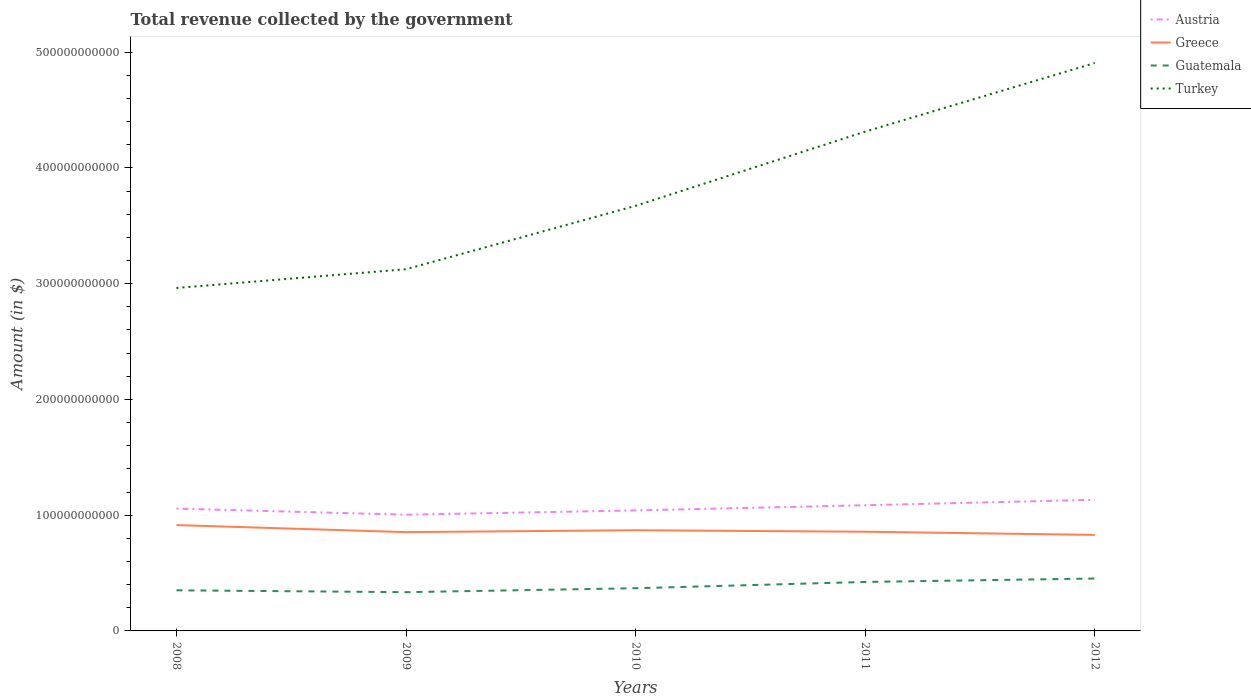How many different coloured lines are there?
Provide a short and direct response. 4. Does the line corresponding to Austria intersect with the line corresponding to Greece?
Provide a short and direct response. No. Is the number of lines equal to the number of legend labels?
Provide a succinct answer. Yes. Across all years, what is the maximum total revenue collected by the government in Austria?
Your answer should be very brief. 1.00e+11. In which year was the total revenue collected by the government in Greece maximum?
Offer a terse response. 2012. What is the total total revenue collected by the government in Greece in the graph?
Ensure brevity in your answer.  2.75e+09. What is the difference between the highest and the second highest total revenue collected by the government in Turkey?
Your response must be concise. 1.94e+11. Is the total revenue collected by the government in Turkey strictly greater than the total revenue collected by the government in Guatemala over the years?
Keep it short and to the point. No. How many years are there in the graph?
Your answer should be compact. 5. What is the difference between two consecutive major ticks on the Y-axis?
Offer a terse response. 1.00e+11. Does the graph contain any zero values?
Provide a short and direct response. No. How many legend labels are there?
Give a very brief answer. 4. How are the legend labels stacked?
Ensure brevity in your answer.  Vertical. What is the title of the graph?
Keep it short and to the point. Total revenue collected by the government. Does "St. Martin (French part)" appear as one of the legend labels in the graph?
Give a very brief answer. No. What is the label or title of the X-axis?
Keep it short and to the point. Years. What is the label or title of the Y-axis?
Offer a very short reply. Amount (in $). What is the Amount (in $) in Austria in 2008?
Make the answer very short. 1.06e+11. What is the Amount (in $) of Greece in 2008?
Your response must be concise. 9.14e+1. What is the Amount (in $) in Guatemala in 2008?
Your answer should be compact. 3.51e+1. What is the Amount (in $) in Turkey in 2008?
Your answer should be very brief. 2.96e+11. What is the Amount (in $) of Austria in 2009?
Offer a terse response. 1.00e+11. What is the Amount (in $) of Greece in 2009?
Make the answer very short. 8.53e+1. What is the Amount (in $) of Guatemala in 2009?
Make the answer very short. 3.35e+1. What is the Amount (in $) of Turkey in 2009?
Offer a terse response. 3.12e+11. What is the Amount (in $) of Austria in 2010?
Provide a succinct answer. 1.04e+11. What is the Amount (in $) in Greece in 2010?
Make the answer very short. 8.70e+1. What is the Amount (in $) in Guatemala in 2010?
Offer a very short reply. 3.69e+1. What is the Amount (in $) in Turkey in 2010?
Make the answer very short. 3.67e+11. What is the Amount (in $) in Austria in 2011?
Provide a short and direct response. 1.09e+11. What is the Amount (in $) in Greece in 2011?
Your response must be concise. 8.57e+1. What is the Amount (in $) of Guatemala in 2011?
Your answer should be compact. 4.23e+1. What is the Amount (in $) in Turkey in 2011?
Keep it short and to the point. 4.31e+11. What is the Amount (in $) of Austria in 2012?
Your answer should be compact. 1.13e+11. What is the Amount (in $) in Greece in 2012?
Your response must be concise. 8.29e+1. What is the Amount (in $) in Guatemala in 2012?
Offer a terse response. 4.53e+1. What is the Amount (in $) of Turkey in 2012?
Provide a short and direct response. 4.91e+11. Across all years, what is the maximum Amount (in $) in Austria?
Your response must be concise. 1.13e+11. Across all years, what is the maximum Amount (in $) in Greece?
Make the answer very short. 9.14e+1. Across all years, what is the maximum Amount (in $) of Guatemala?
Provide a short and direct response. 4.53e+1. Across all years, what is the maximum Amount (in $) of Turkey?
Provide a succinct answer. 4.91e+11. Across all years, what is the minimum Amount (in $) of Austria?
Provide a short and direct response. 1.00e+11. Across all years, what is the minimum Amount (in $) of Greece?
Ensure brevity in your answer.  8.29e+1. Across all years, what is the minimum Amount (in $) of Guatemala?
Offer a terse response. 3.35e+1. Across all years, what is the minimum Amount (in $) of Turkey?
Keep it short and to the point. 2.96e+11. What is the total Amount (in $) in Austria in the graph?
Provide a succinct answer. 5.32e+11. What is the total Amount (in $) of Greece in the graph?
Your answer should be compact. 4.32e+11. What is the total Amount (in $) in Guatemala in the graph?
Your answer should be compact. 1.93e+11. What is the total Amount (in $) of Turkey in the graph?
Your response must be concise. 1.90e+12. What is the difference between the Amount (in $) of Austria in 2008 and that in 2009?
Your response must be concise. 5.25e+09. What is the difference between the Amount (in $) of Greece in 2008 and that in 2009?
Make the answer very short. 6.07e+09. What is the difference between the Amount (in $) in Guatemala in 2008 and that in 2009?
Provide a succinct answer. 1.61e+09. What is the difference between the Amount (in $) in Turkey in 2008 and that in 2009?
Ensure brevity in your answer.  -1.62e+1. What is the difference between the Amount (in $) in Austria in 2008 and that in 2010?
Ensure brevity in your answer.  1.57e+09. What is the difference between the Amount (in $) in Greece in 2008 and that in 2010?
Ensure brevity in your answer.  4.44e+09. What is the difference between the Amount (in $) of Guatemala in 2008 and that in 2010?
Offer a very short reply. -1.79e+09. What is the difference between the Amount (in $) of Turkey in 2008 and that in 2010?
Provide a short and direct response. -7.10e+1. What is the difference between the Amount (in $) of Austria in 2008 and that in 2011?
Offer a very short reply. -2.92e+09. What is the difference between the Amount (in $) of Greece in 2008 and that in 2011?
Make the answer very short. 5.73e+09. What is the difference between the Amount (in $) of Guatemala in 2008 and that in 2011?
Give a very brief answer. -7.21e+09. What is the difference between the Amount (in $) of Turkey in 2008 and that in 2011?
Keep it short and to the point. -1.35e+11. What is the difference between the Amount (in $) of Austria in 2008 and that in 2012?
Make the answer very short. -7.61e+09. What is the difference between the Amount (in $) of Greece in 2008 and that in 2012?
Give a very brief answer. 8.48e+09. What is the difference between the Amount (in $) of Guatemala in 2008 and that in 2012?
Ensure brevity in your answer.  -1.02e+1. What is the difference between the Amount (in $) in Turkey in 2008 and that in 2012?
Keep it short and to the point. -1.94e+11. What is the difference between the Amount (in $) in Austria in 2009 and that in 2010?
Give a very brief answer. -3.68e+09. What is the difference between the Amount (in $) of Greece in 2009 and that in 2010?
Your answer should be very brief. -1.63e+09. What is the difference between the Amount (in $) in Guatemala in 2009 and that in 2010?
Your answer should be compact. -3.40e+09. What is the difference between the Amount (in $) in Turkey in 2009 and that in 2010?
Your answer should be very brief. -5.48e+1. What is the difference between the Amount (in $) in Austria in 2009 and that in 2011?
Your answer should be very brief. -8.17e+09. What is the difference between the Amount (in $) in Greece in 2009 and that in 2011?
Make the answer very short. -3.43e+08. What is the difference between the Amount (in $) of Guatemala in 2009 and that in 2011?
Ensure brevity in your answer.  -8.81e+09. What is the difference between the Amount (in $) in Turkey in 2009 and that in 2011?
Your response must be concise. -1.19e+11. What is the difference between the Amount (in $) in Austria in 2009 and that in 2012?
Ensure brevity in your answer.  -1.29e+1. What is the difference between the Amount (in $) of Greece in 2009 and that in 2012?
Make the answer very short. 2.40e+09. What is the difference between the Amount (in $) of Guatemala in 2009 and that in 2012?
Offer a very short reply. -1.18e+1. What is the difference between the Amount (in $) of Turkey in 2009 and that in 2012?
Give a very brief answer. -1.78e+11. What is the difference between the Amount (in $) of Austria in 2010 and that in 2011?
Make the answer very short. -4.49e+09. What is the difference between the Amount (in $) of Greece in 2010 and that in 2011?
Ensure brevity in your answer.  1.28e+09. What is the difference between the Amount (in $) in Guatemala in 2010 and that in 2011?
Provide a succinct answer. -5.42e+09. What is the difference between the Amount (in $) in Turkey in 2010 and that in 2011?
Provide a succinct answer. -6.41e+1. What is the difference between the Amount (in $) of Austria in 2010 and that in 2012?
Offer a very short reply. -9.19e+09. What is the difference between the Amount (in $) of Greece in 2010 and that in 2012?
Offer a very short reply. 4.03e+09. What is the difference between the Amount (in $) of Guatemala in 2010 and that in 2012?
Your answer should be very brief. -8.40e+09. What is the difference between the Amount (in $) in Turkey in 2010 and that in 2012?
Give a very brief answer. -1.23e+11. What is the difference between the Amount (in $) of Austria in 2011 and that in 2012?
Provide a short and direct response. -4.69e+09. What is the difference between the Amount (in $) of Greece in 2011 and that in 2012?
Ensure brevity in your answer.  2.75e+09. What is the difference between the Amount (in $) in Guatemala in 2011 and that in 2012?
Ensure brevity in your answer.  -2.98e+09. What is the difference between the Amount (in $) in Turkey in 2011 and that in 2012?
Your response must be concise. -5.93e+1. What is the difference between the Amount (in $) of Austria in 2008 and the Amount (in $) of Greece in 2009?
Give a very brief answer. 2.03e+1. What is the difference between the Amount (in $) in Austria in 2008 and the Amount (in $) in Guatemala in 2009?
Give a very brief answer. 7.22e+1. What is the difference between the Amount (in $) in Austria in 2008 and the Amount (in $) in Turkey in 2009?
Provide a succinct answer. -2.07e+11. What is the difference between the Amount (in $) of Greece in 2008 and the Amount (in $) of Guatemala in 2009?
Provide a short and direct response. 5.79e+1. What is the difference between the Amount (in $) of Greece in 2008 and the Amount (in $) of Turkey in 2009?
Give a very brief answer. -2.21e+11. What is the difference between the Amount (in $) of Guatemala in 2008 and the Amount (in $) of Turkey in 2009?
Make the answer very short. -2.77e+11. What is the difference between the Amount (in $) in Austria in 2008 and the Amount (in $) in Greece in 2010?
Provide a succinct answer. 1.87e+1. What is the difference between the Amount (in $) in Austria in 2008 and the Amount (in $) in Guatemala in 2010?
Provide a short and direct response. 6.88e+1. What is the difference between the Amount (in $) in Austria in 2008 and the Amount (in $) in Turkey in 2010?
Offer a very short reply. -2.62e+11. What is the difference between the Amount (in $) in Greece in 2008 and the Amount (in $) in Guatemala in 2010?
Your response must be concise. 5.45e+1. What is the difference between the Amount (in $) in Greece in 2008 and the Amount (in $) in Turkey in 2010?
Offer a terse response. -2.76e+11. What is the difference between the Amount (in $) of Guatemala in 2008 and the Amount (in $) of Turkey in 2010?
Your response must be concise. -3.32e+11. What is the difference between the Amount (in $) in Austria in 2008 and the Amount (in $) in Greece in 2011?
Offer a very short reply. 2.00e+1. What is the difference between the Amount (in $) of Austria in 2008 and the Amount (in $) of Guatemala in 2011?
Your answer should be compact. 6.34e+1. What is the difference between the Amount (in $) of Austria in 2008 and the Amount (in $) of Turkey in 2011?
Offer a very short reply. -3.26e+11. What is the difference between the Amount (in $) in Greece in 2008 and the Amount (in $) in Guatemala in 2011?
Provide a short and direct response. 4.91e+1. What is the difference between the Amount (in $) in Greece in 2008 and the Amount (in $) in Turkey in 2011?
Give a very brief answer. -3.40e+11. What is the difference between the Amount (in $) of Guatemala in 2008 and the Amount (in $) of Turkey in 2011?
Make the answer very short. -3.96e+11. What is the difference between the Amount (in $) of Austria in 2008 and the Amount (in $) of Greece in 2012?
Provide a short and direct response. 2.27e+1. What is the difference between the Amount (in $) in Austria in 2008 and the Amount (in $) in Guatemala in 2012?
Provide a succinct answer. 6.04e+1. What is the difference between the Amount (in $) of Austria in 2008 and the Amount (in $) of Turkey in 2012?
Ensure brevity in your answer.  -3.85e+11. What is the difference between the Amount (in $) in Greece in 2008 and the Amount (in $) in Guatemala in 2012?
Provide a short and direct response. 4.61e+1. What is the difference between the Amount (in $) of Greece in 2008 and the Amount (in $) of Turkey in 2012?
Offer a terse response. -3.99e+11. What is the difference between the Amount (in $) in Guatemala in 2008 and the Amount (in $) in Turkey in 2012?
Offer a terse response. -4.55e+11. What is the difference between the Amount (in $) of Austria in 2009 and the Amount (in $) of Greece in 2010?
Keep it short and to the point. 1.34e+1. What is the difference between the Amount (in $) of Austria in 2009 and the Amount (in $) of Guatemala in 2010?
Ensure brevity in your answer.  6.35e+1. What is the difference between the Amount (in $) in Austria in 2009 and the Amount (in $) in Turkey in 2010?
Your response must be concise. -2.67e+11. What is the difference between the Amount (in $) in Greece in 2009 and the Amount (in $) in Guatemala in 2010?
Offer a very short reply. 4.85e+1. What is the difference between the Amount (in $) of Greece in 2009 and the Amount (in $) of Turkey in 2010?
Ensure brevity in your answer.  -2.82e+11. What is the difference between the Amount (in $) of Guatemala in 2009 and the Amount (in $) of Turkey in 2010?
Your response must be concise. -3.34e+11. What is the difference between the Amount (in $) in Austria in 2009 and the Amount (in $) in Greece in 2011?
Ensure brevity in your answer.  1.47e+1. What is the difference between the Amount (in $) in Austria in 2009 and the Amount (in $) in Guatemala in 2011?
Your answer should be compact. 5.81e+1. What is the difference between the Amount (in $) in Austria in 2009 and the Amount (in $) in Turkey in 2011?
Make the answer very short. -3.31e+11. What is the difference between the Amount (in $) in Greece in 2009 and the Amount (in $) in Guatemala in 2011?
Offer a very short reply. 4.30e+1. What is the difference between the Amount (in $) in Greece in 2009 and the Amount (in $) in Turkey in 2011?
Offer a very short reply. -3.46e+11. What is the difference between the Amount (in $) in Guatemala in 2009 and the Amount (in $) in Turkey in 2011?
Your answer should be very brief. -3.98e+11. What is the difference between the Amount (in $) in Austria in 2009 and the Amount (in $) in Greece in 2012?
Give a very brief answer. 1.75e+1. What is the difference between the Amount (in $) of Austria in 2009 and the Amount (in $) of Guatemala in 2012?
Give a very brief answer. 5.51e+1. What is the difference between the Amount (in $) in Austria in 2009 and the Amount (in $) in Turkey in 2012?
Your response must be concise. -3.90e+11. What is the difference between the Amount (in $) of Greece in 2009 and the Amount (in $) of Guatemala in 2012?
Make the answer very short. 4.01e+1. What is the difference between the Amount (in $) of Greece in 2009 and the Amount (in $) of Turkey in 2012?
Your response must be concise. -4.05e+11. What is the difference between the Amount (in $) of Guatemala in 2009 and the Amount (in $) of Turkey in 2012?
Your response must be concise. -4.57e+11. What is the difference between the Amount (in $) in Austria in 2010 and the Amount (in $) in Greece in 2011?
Make the answer very short. 1.84e+1. What is the difference between the Amount (in $) of Austria in 2010 and the Amount (in $) of Guatemala in 2011?
Provide a succinct answer. 6.18e+1. What is the difference between the Amount (in $) of Austria in 2010 and the Amount (in $) of Turkey in 2011?
Make the answer very short. -3.27e+11. What is the difference between the Amount (in $) in Greece in 2010 and the Amount (in $) in Guatemala in 2011?
Your response must be concise. 4.47e+1. What is the difference between the Amount (in $) of Greece in 2010 and the Amount (in $) of Turkey in 2011?
Offer a terse response. -3.44e+11. What is the difference between the Amount (in $) of Guatemala in 2010 and the Amount (in $) of Turkey in 2011?
Ensure brevity in your answer.  -3.94e+11. What is the difference between the Amount (in $) in Austria in 2010 and the Amount (in $) in Greece in 2012?
Keep it short and to the point. 2.11e+1. What is the difference between the Amount (in $) of Austria in 2010 and the Amount (in $) of Guatemala in 2012?
Offer a terse response. 5.88e+1. What is the difference between the Amount (in $) of Austria in 2010 and the Amount (in $) of Turkey in 2012?
Make the answer very short. -3.86e+11. What is the difference between the Amount (in $) of Greece in 2010 and the Amount (in $) of Guatemala in 2012?
Your response must be concise. 4.17e+1. What is the difference between the Amount (in $) of Greece in 2010 and the Amount (in $) of Turkey in 2012?
Provide a short and direct response. -4.04e+11. What is the difference between the Amount (in $) in Guatemala in 2010 and the Amount (in $) in Turkey in 2012?
Your response must be concise. -4.54e+11. What is the difference between the Amount (in $) in Austria in 2011 and the Amount (in $) in Greece in 2012?
Make the answer very short. 2.56e+1. What is the difference between the Amount (in $) of Austria in 2011 and the Amount (in $) of Guatemala in 2012?
Your response must be concise. 6.33e+1. What is the difference between the Amount (in $) in Austria in 2011 and the Amount (in $) in Turkey in 2012?
Make the answer very short. -3.82e+11. What is the difference between the Amount (in $) of Greece in 2011 and the Amount (in $) of Guatemala in 2012?
Your response must be concise. 4.04e+1. What is the difference between the Amount (in $) in Greece in 2011 and the Amount (in $) in Turkey in 2012?
Ensure brevity in your answer.  -4.05e+11. What is the difference between the Amount (in $) in Guatemala in 2011 and the Amount (in $) in Turkey in 2012?
Make the answer very short. -4.48e+11. What is the average Amount (in $) in Austria per year?
Your answer should be compact. 1.06e+11. What is the average Amount (in $) of Greece per year?
Your answer should be very brief. 8.65e+1. What is the average Amount (in $) of Guatemala per year?
Ensure brevity in your answer.  3.86e+1. What is the average Amount (in $) in Turkey per year?
Give a very brief answer. 3.80e+11. In the year 2008, what is the difference between the Amount (in $) in Austria and Amount (in $) in Greece?
Offer a terse response. 1.42e+1. In the year 2008, what is the difference between the Amount (in $) in Austria and Amount (in $) in Guatemala?
Your answer should be compact. 7.06e+1. In the year 2008, what is the difference between the Amount (in $) in Austria and Amount (in $) in Turkey?
Keep it short and to the point. -1.91e+11. In the year 2008, what is the difference between the Amount (in $) in Greece and Amount (in $) in Guatemala?
Provide a succinct answer. 5.63e+1. In the year 2008, what is the difference between the Amount (in $) in Greece and Amount (in $) in Turkey?
Your answer should be very brief. -2.05e+11. In the year 2008, what is the difference between the Amount (in $) in Guatemala and Amount (in $) in Turkey?
Provide a succinct answer. -2.61e+11. In the year 2009, what is the difference between the Amount (in $) of Austria and Amount (in $) of Greece?
Your response must be concise. 1.51e+1. In the year 2009, what is the difference between the Amount (in $) of Austria and Amount (in $) of Guatemala?
Provide a succinct answer. 6.69e+1. In the year 2009, what is the difference between the Amount (in $) of Austria and Amount (in $) of Turkey?
Your answer should be very brief. -2.12e+11. In the year 2009, what is the difference between the Amount (in $) of Greece and Amount (in $) of Guatemala?
Offer a terse response. 5.19e+1. In the year 2009, what is the difference between the Amount (in $) in Greece and Amount (in $) in Turkey?
Make the answer very short. -2.27e+11. In the year 2009, what is the difference between the Amount (in $) of Guatemala and Amount (in $) of Turkey?
Make the answer very short. -2.79e+11. In the year 2010, what is the difference between the Amount (in $) of Austria and Amount (in $) of Greece?
Make the answer very short. 1.71e+1. In the year 2010, what is the difference between the Amount (in $) in Austria and Amount (in $) in Guatemala?
Your answer should be very brief. 6.72e+1. In the year 2010, what is the difference between the Amount (in $) of Austria and Amount (in $) of Turkey?
Your answer should be compact. -2.63e+11. In the year 2010, what is the difference between the Amount (in $) of Greece and Amount (in $) of Guatemala?
Your response must be concise. 5.01e+1. In the year 2010, what is the difference between the Amount (in $) of Greece and Amount (in $) of Turkey?
Your answer should be very brief. -2.80e+11. In the year 2010, what is the difference between the Amount (in $) of Guatemala and Amount (in $) of Turkey?
Ensure brevity in your answer.  -3.30e+11. In the year 2011, what is the difference between the Amount (in $) in Austria and Amount (in $) in Greece?
Provide a short and direct response. 2.29e+1. In the year 2011, what is the difference between the Amount (in $) in Austria and Amount (in $) in Guatemala?
Ensure brevity in your answer.  6.63e+1. In the year 2011, what is the difference between the Amount (in $) of Austria and Amount (in $) of Turkey?
Offer a very short reply. -3.23e+11. In the year 2011, what is the difference between the Amount (in $) in Greece and Amount (in $) in Guatemala?
Your response must be concise. 4.34e+1. In the year 2011, what is the difference between the Amount (in $) of Greece and Amount (in $) of Turkey?
Provide a succinct answer. -3.46e+11. In the year 2011, what is the difference between the Amount (in $) of Guatemala and Amount (in $) of Turkey?
Offer a very short reply. -3.89e+11. In the year 2012, what is the difference between the Amount (in $) in Austria and Amount (in $) in Greece?
Your response must be concise. 3.03e+1. In the year 2012, what is the difference between the Amount (in $) of Austria and Amount (in $) of Guatemala?
Offer a terse response. 6.80e+1. In the year 2012, what is the difference between the Amount (in $) of Austria and Amount (in $) of Turkey?
Offer a terse response. -3.77e+11. In the year 2012, what is the difference between the Amount (in $) of Greece and Amount (in $) of Guatemala?
Ensure brevity in your answer.  3.77e+1. In the year 2012, what is the difference between the Amount (in $) in Greece and Amount (in $) in Turkey?
Provide a short and direct response. -4.08e+11. In the year 2012, what is the difference between the Amount (in $) of Guatemala and Amount (in $) of Turkey?
Keep it short and to the point. -4.45e+11. What is the ratio of the Amount (in $) of Austria in 2008 to that in 2009?
Give a very brief answer. 1.05. What is the ratio of the Amount (in $) of Greece in 2008 to that in 2009?
Your response must be concise. 1.07. What is the ratio of the Amount (in $) in Guatemala in 2008 to that in 2009?
Your response must be concise. 1.05. What is the ratio of the Amount (in $) in Turkey in 2008 to that in 2009?
Make the answer very short. 0.95. What is the ratio of the Amount (in $) of Austria in 2008 to that in 2010?
Provide a short and direct response. 1.02. What is the ratio of the Amount (in $) of Greece in 2008 to that in 2010?
Ensure brevity in your answer.  1.05. What is the ratio of the Amount (in $) in Guatemala in 2008 to that in 2010?
Provide a succinct answer. 0.95. What is the ratio of the Amount (in $) in Turkey in 2008 to that in 2010?
Your answer should be very brief. 0.81. What is the ratio of the Amount (in $) in Austria in 2008 to that in 2011?
Keep it short and to the point. 0.97. What is the ratio of the Amount (in $) in Greece in 2008 to that in 2011?
Your answer should be very brief. 1.07. What is the ratio of the Amount (in $) in Guatemala in 2008 to that in 2011?
Offer a terse response. 0.83. What is the ratio of the Amount (in $) in Turkey in 2008 to that in 2011?
Offer a very short reply. 0.69. What is the ratio of the Amount (in $) in Austria in 2008 to that in 2012?
Provide a succinct answer. 0.93. What is the ratio of the Amount (in $) in Greece in 2008 to that in 2012?
Your response must be concise. 1.1. What is the ratio of the Amount (in $) in Guatemala in 2008 to that in 2012?
Offer a terse response. 0.78. What is the ratio of the Amount (in $) in Turkey in 2008 to that in 2012?
Keep it short and to the point. 0.6. What is the ratio of the Amount (in $) in Austria in 2009 to that in 2010?
Your response must be concise. 0.96. What is the ratio of the Amount (in $) in Greece in 2009 to that in 2010?
Give a very brief answer. 0.98. What is the ratio of the Amount (in $) in Guatemala in 2009 to that in 2010?
Keep it short and to the point. 0.91. What is the ratio of the Amount (in $) of Turkey in 2009 to that in 2010?
Offer a very short reply. 0.85. What is the ratio of the Amount (in $) in Austria in 2009 to that in 2011?
Offer a very short reply. 0.92. What is the ratio of the Amount (in $) in Greece in 2009 to that in 2011?
Your response must be concise. 1. What is the ratio of the Amount (in $) of Guatemala in 2009 to that in 2011?
Keep it short and to the point. 0.79. What is the ratio of the Amount (in $) in Turkey in 2009 to that in 2011?
Offer a very short reply. 0.72. What is the ratio of the Amount (in $) in Austria in 2009 to that in 2012?
Provide a short and direct response. 0.89. What is the ratio of the Amount (in $) in Greece in 2009 to that in 2012?
Offer a very short reply. 1.03. What is the ratio of the Amount (in $) in Guatemala in 2009 to that in 2012?
Offer a very short reply. 0.74. What is the ratio of the Amount (in $) of Turkey in 2009 to that in 2012?
Provide a succinct answer. 0.64. What is the ratio of the Amount (in $) in Austria in 2010 to that in 2011?
Give a very brief answer. 0.96. What is the ratio of the Amount (in $) of Greece in 2010 to that in 2011?
Your answer should be compact. 1.01. What is the ratio of the Amount (in $) of Guatemala in 2010 to that in 2011?
Offer a terse response. 0.87. What is the ratio of the Amount (in $) of Turkey in 2010 to that in 2011?
Keep it short and to the point. 0.85. What is the ratio of the Amount (in $) of Austria in 2010 to that in 2012?
Your response must be concise. 0.92. What is the ratio of the Amount (in $) of Greece in 2010 to that in 2012?
Your answer should be compact. 1.05. What is the ratio of the Amount (in $) of Guatemala in 2010 to that in 2012?
Provide a succinct answer. 0.81. What is the ratio of the Amount (in $) in Turkey in 2010 to that in 2012?
Offer a terse response. 0.75. What is the ratio of the Amount (in $) in Austria in 2011 to that in 2012?
Make the answer very short. 0.96. What is the ratio of the Amount (in $) in Greece in 2011 to that in 2012?
Your answer should be very brief. 1.03. What is the ratio of the Amount (in $) in Guatemala in 2011 to that in 2012?
Make the answer very short. 0.93. What is the ratio of the Amount (in $) in Turkey in 2011 to that in 2012?
Provide a succinct answer. 0.88. What is the difference between the highest and the second highest Amount (in $) in Austria?
Ensure brevity in your answer.  4.69e+09. What is the difference between the highest and the second highest Amount (in $) in Greece?
Ensure brevity in your answer.  4.44e+09. What is the difference between the highest and the second highest Amount (in $) of Guatemala?
Your answer should be very brief. 2.98e+09. What is the difference between the highest and the second highest Amount (in $) in Turkey?
Provide a succinct answer. 5.93e+1. What is the difference between the highest and the lowest Amount (in $) of Austria?
Provide a succinct answer. 1.29e+1. What is the difference between the highest and the lowest Amount (in $) in Greece?
Your response must be concise. 8.48e+09. What is the difference between the highest and the lowest Amount (in $) of Guatemala?
Keep it short and to the point. 1.18e+1. What is the difference between the highest and the lowest Amount (in $) of Turkey?
Give a very brief answer. 1.94e+11. 